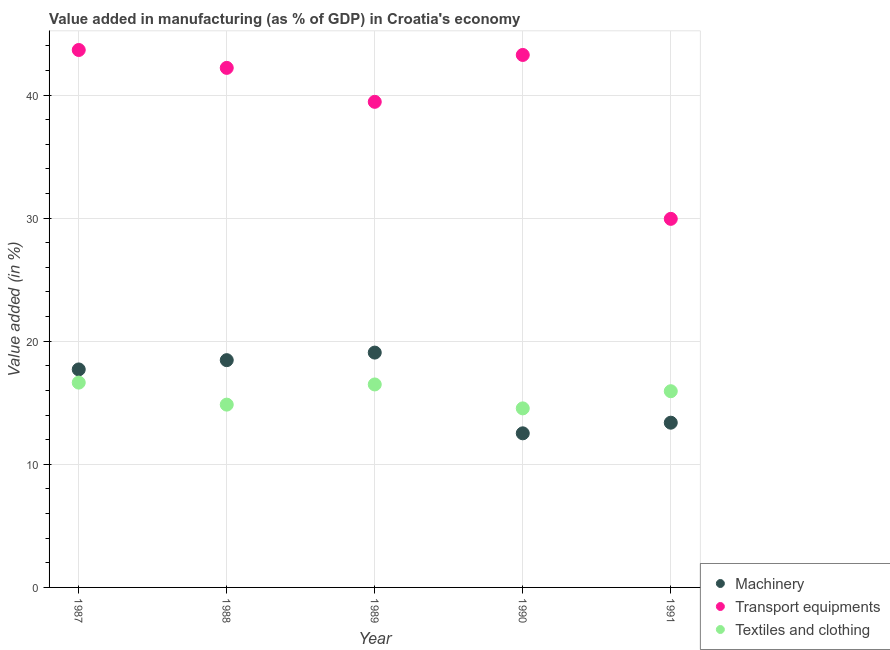How many different coloured dotlines are there?
Ensure brevity in your answer.  3. Is the number of dotlines equal to the number of legend labels?
Make the answer very short. Yes. What is the value added in manufacturing machinery in 1987?
Provide a succinct answer. 17.71. Across all years, what is the maximum value added in manufacturing textile and clothing?
Your answer should be compact. 16.64. Across all years, what is the minimum value added in manufacturing transport equipments?
Provide a short and direct response. 29.94. In which year was the value added in manufacturing textile and clothing maximum?
Provide a short and direct response. 1987. What is the total value added in manufacturing machinery in the graph?
Give a very brief answer. 81.15. What is the difference between the value added in manufacturing transport equipments in 1987 and that in 1990?
Keep it short and to the point. 0.4. What is the difference between the value added in manufacturing machinery in 1987 and the value added in manufacturing textile and clothing in 1988?
Offer a very short reply. 2.86. What is the average value added in manufacturing textile and clothing per year?
Provide a short and direct response. 15.69. In the year 1990, what is the difference between the value added in manufacturing transport equipments and value added in manufacturing textile and clothing?
Give a very brief answer. 28.71. What is the ratio of the value added in manufacturing machinery in 1988 to that in 1991?
Your answer should be compact. 1.38. Is the difference between the value added in manufacturing machinery in 1988 and 1990 greater than the difference between the value added in manufacturing transport equipments in 1988 and 1990?
Give a very brief answer. Yes. What is the difference between the highest and the second highest value added in manufacturing textile and clothing?
Give a very brief answer. 0.15. What is the difference between the highest and the lowest value added in manufacturing machinery?
Your answer should be very brief. 6.56. In how many years, is the value added in manufacturing machinery greater than the average value added in manufacturing machinery taken over all years?
Offer a very short reply. 3. Is the sum of the value added in manufacturing transport equipments in 1990 and 1991 greater than the maximum value added in manufacturing machinery across all years?
Your answer should be compact. Yes. Is the value added in manufacturing transport equipments strictly less than the value added in manufacturing machinery over the years?
Ensure brevity in your answer.  No. How many dotlines are there?
Ensure brevity in your answer.  3. What is the difference between two consecutive major ticks on the Y-axis?
Offer a terse response. 10. Are the values on the major ticks of Y-axis written in scientific E-notation?
Make the answer very short. No. What is the title of the graph?
Give a very brief answer. Value added in manufacturing (as % of GDP) in Croatia's economy. What is the label or title of the Y-axis?
Your answer should be very brief. Value added (in %). What is the Value added (in %) in Machinery in 1987?
Your answer should be very brief. 17.71. What is the Value added (in %) of Transport equipments in 1987?
Give a very brief answer. 43.66. What is the Value added (in %) in Textiles and clothing in 1987?
Offer a very short reply. 16.64. What is the Value added (in %) in Machinery in 1988?
Ensure brevity in your answer.  18.46. What is the Value added (in %) of Transport equipments in 1988?
Offer a terse response. 42.2. What is the Value added (in %) of Textiles and clothing in 1988?
Offer a terse response. 14.85. What is the Value added (in %) in Machinery in 1989?
Offer a terse response. 19.08. What is the Value added (in %) in Transport equipments in 1989?
Make the answer very short. 39.44. What is the Value added (in %) of Textiles and clothing in 1989?
Your response must be concise. 16.49. What is the Value added (in %) of Machinery in 1990?
Ensure brevity in your answer.  12.52. What is the Value added (in %) of Transport equipments in 1990?
Provide a succinct answer. 43.25. What is the Value added (in %) in Textiles and clothing in 1990?
Ensure brevity in your answer.  14.54. What is the Value added (in %) in Machinery in 1991?
Ensure brevity in your answer.  13.38. What is the Value added (in %) of Transport equipments in 1991?
Your response must be concise. 29.94. What is the Value added (in %) in Textiles and clothing in 1991?
Provide a succinct answer. 15.94. Across all years, what is the maximum Value added (in %) of Machinery?
Make the answer very short. 19.08. Across all years, what is the maximum Value added (in %) of Transport equipments?
Keep it short and to the point. 43.66. Across all years, what is the maximum Value added (in %) of Textiles and clothing?
Your answer should be compact. 16.64. Across all years, what is the minimum Value added (in %) in Machinery?
Provide a succinct answer. 12.52. Across all years, what is the minimum Value added (in %) in Transport equipments?
Your answer should be very brief. 29.94. Across all years, what is the minimum Value added (in %) in Textiles and clothing?
Give a very brief answer. 14.54. What is the total Value added (in %) in Machinery in the graph?
Offer a very short reply. 81.15. What is the total Value added (in %) in Transport equipments in the graph?
Provide a succinct answer. 198.5. What is the total Value added (in %) of Textiles and clothing in the graph?
Make the answer very short. 78.46. What is the difference between the Value added (in %) of Machinery in 1987 and that in 1988?
Offer a very short reply. -0.75. What is the difference between the Value added (in %) in Transport equipments in 1987 and that in 1988?
Ensure brevity in your answer.  1.45. What is the difference between the Value added (in %) of Textiles and clothing in 1987 and that in 1988?
Offer a terse response. 1.79. What is the difference between the Value added (in %) in Machinery in 1987 and that in 1989?
Offer a terse response. -1.37. What is the difference between the Value added (in %) in Transport equipments in 1987 and that in 1989?
Give a very brief answer. 4.21. What is the difference between the Value added (in %) in Textiles and clothing in 1987 and that in 1989?
Provide a succinct answer. 0.15. What is the difference between the Value added (in %) of Machinery in 1987 and that in 1990?
Give a very brief answer. 5.19. What is the difference between the Value added (in %) in Transport equipments in 1987 and that in 1990?
Provide a succinct answer. 0.4. What is the difference between the Value added (in %) of Textiles and clothing in 1987 and that in 1990?
Offer a terse response. 2.09. What is the difference between the Value added (in %) in Machinery in 1987 and that in 1991?
Offer a terse response. 4.33. What is the difference between the Value added (in %) of Transport equipments in 1987 and that in 1991?
Ensure brevity in your answer.  13.72. What is the difference between the Value added (in %) in Textiles and clothing in 1987 and that in 1991?
Keep it short and to the point. 0.7. What is the difference between the Value added (in %) in Machinery in 1988 and that in 1989?
Make the answer very short. -0.61. What is the difference between the Value added (in %) of Transport equipments in 1988 and that in 1989?
Provide a short and direct response. 2.76. What is the difference between the Value added (in %) in Textiles and clothing in 1988 and that in 1989?
Your answer should be very brief. -1.64. What is the difference between the Value added (in %) of Machinery in 1988 and that in 1990?
Your answer should be very brief. 5.94. What is the difference between the Value added (in %) in Transport equipments in 1988 and that in 1990?
Keep it short and to the point. -1.05. What is the difference between the Value added (in %) of Textiles and clothing in 1988 and that in 1990?
Your answer should be very brief. 0.31. What is the difference between the Value added (in %) in Machinery in 1988 and that in 1991?
Provide a short and direct response. 5.08. What is the difference between the Value added (in %) of Transport equipments in 1988 and that in 1991?
Ensure brevity in your answer.  12.26. What is the difference between the Value added (in %) of Textiles and clothing in 1988 and that in 1991?
Offer a terse response. -1.09. What is the difference between the Value added (in %) in Machinery in 1989 and that in 1990?
Make the answer very short. 6.56. What is the difference between the Value added (in %) of Transport equipments in 1989 and that in 1990?
Give a very brief answer. -3.81. What is the difference between the Value added (in %) of Textiles and clothing in 1989 and that in 1990?
Offer a terse response. 1.94. What is the difference between the Value added (in %) in Machinery in 1989 and that in 1991?
Give a very brief answer. 5.69. What is the difference between the Value added (in %) of Transport equipments in 1989 and that in 1991?
Keep it short and to the point. 9.51. What is the difference between the Value added (in %) in Textiles and clothing in 1989 and that in 1991?
Your answer should be compact. 0.55. What is the difference between the Value added (in %) of Machinery in 1990 and that in 1991?
Offer a terse response. -0.86. What is the difference between the Value added (in %) in Transport equipments in 1990 and that in 1991?
Offer a very short reply. 13.31. What is the difference between the Value added (in %) in Textiles and clothing in 1990 and that in 1991?
Your answer should be very brief. -1.39. What is the difference between the Value added (in %) in Machinery in 1987 and the Value added (in %) in Transport equipments in 1988?
Provide a short and direct response. -24.49. What is the difference between the Value added (in %) in Machinery in 1987 and the Value added (in %) in Textiles and clothing in 1988?
Your response must be concise. 2.86. What is the difference between the Value added (in %) in Transport equipments in 1987 and the Value added (in %) in Textiles and clothing in 1988?
Give a very brief answer. 28.81. What is the difference between the Value added (in %) in Machinery in 1987 and the Value added (in %) in Transport equipments in 1989?
Your answer should be compact. -21.74. What is the difference between the Value added (in %) of Machinery in 1987 and the Value added (in %) of Textiles and clothing in 1989?
Your answer should be compact. 1.22. What is the difference between the Value added (in %) of Transport equipments in 1987 and the Value added (in %) of Textiles and clothing in 1989?
Your answer should be very brief. 27.17. What is the difference between the Value added (in %) in Machinery in 1987 and the Value added (in %) in Transport equipments in 1990?
Provide a short and direct response. -25.54. What is the difference between the Value added (in %) in Machinery in 1987 and the Value added (in %) in Textiles and clothing in 1990?
Offer a terse response. 3.16. What is the difference between the Value added (in %) in Transport equipments in 1987 and the Value added (in %) in Textiles and clothing in 1990?
Provide a succinct answer. 29.11. What is the difference between the Value added (in %) of Machinery in 1987 and the Value added (in %) of Transport equipments in 1991?
Your response must be concise. -12.23. What is the difference between the Value added (in %) of Machinery in 1987 and the Value added (in %) of Textiles and clothing in 1991?
Your response must be concise. 1.77. What is the difference between the Value added (in %) in Transport equipments in 1987 and the Value added (in %) in Textiles and clothing in 1991?
Offer a terse response. 27.72. What is the difference between the Value added (in %) in Machinery in 1988 and the Value added (in %) in Transport equipments in 1989?
Your answer should be very brief. -20.98. What is the difference between the Value added (in %) of Machinery in 1988 and the Value added (in %) of Textiles and clothing in 1989?
Provide a succinct answer. 1.97. What is the difference between the Value added (in %) of Transport equipments in 1988 and the Value added (in %) of Textiles and clothing in 1989?
Your answer should be compact. 25.72. What is the difference between the Value added (in %) in Machinery in 1988 and the Value added (in %) in Transport equipments in 1990?
Make the answer very short. -24.79. What is the difference between the Value added (in %) in Machinery in 1988 and the Value added (in %) in Textiles and clothing in 1990?
Provide a succinct answer. 3.92. What is the difference between the Value added (in %) in Transport equipments in 1988 and the Value added (in %) in Textiles and clothing in 1990?
Your answer should be very brief. 27.66. What is the difference between the Value added (in %) in Machinery in 1988 and the Value added (in %) in Transport equipments in 1991?
Keep it short and to the point. -11.48. What is the difference between the Value added (in %) in Machinery in 1988 and the Value added (in %) in Textiles and clothing in 1991?
Your answer should be compact. 2.52. What is the difference between the Value added (in %) in Transport equipments in 1988 and the Value added (in %) in Textiles and clothing in 1991?
Make the answer very short. 26.26. What is the difference between the Value added (in %) in Machinery in 1989 and the Value added (in %) in Transport equipments in 1990?
Make the answer very short. -24.18. What is the difference between the Value added (in %) of Machinery in 1989 and the Value added (in %) of Textiles and clothing in 1990?
Provide a succinct answer. 4.53. What is the difference between the Value added (in %) of Transport equipments in 1989 and the Value added (in %) of Textiles and clothing in 1990?
Your answer should be compact. 24.9. What is the difference between the Value added (in %) in Machinery in 1989 and the Value added (in %) in Transport equipments in 1991?
Offer a terse response. -10.86. What is the difference between the Value added (in %) of Machinery in 1989 and the Value added (in %) of Textiles and clothing in 1991?
Provide a succinct answer. 3.14. What is the difference between the Value added (in %) of Transport equipments in 1989 and the Value added (in %) of Textiles and clothing in 1991?
Make the answer very short. 23.51. What is the difference between the Value added (in %) of Machinery in 1990 and the Value added (in %) of Transport equipments in 1991?
Provide a succinct answer. -17.42. What is the difference between the Value added (in %) of Machinery in 1990 and the Value added (in %) of Textiles and clothing in 1991?
Provide a succinct answer. -3.42. What is the difference between the Value added (in %) of Transport equipments in 1990 and the Value added (in %) of Textiles and clothing in 1991?
Provide a short and direct response. 27.31. What is the average Value added (in %) in Machinery per year?
Keep it short and to the point. 16.23. What is the average Value added (in %) in Transport equipments per year?
Provide a short and direct response. 39.7. What is the average Value added (in %) in Textiles and clothing per year?
Offer a very short reply. 15.69. In the year 1987, what is the difference between the Value added (in %) of Machinery and Value added (in %) of Transport equipments?
Make the answer very short. -25.95. In the year 1987, what is the difference between the Value added (in %) in Machinery and Value added (in %) in Textiles and clothing?
Make the answer very short. 1.07. In the year 1987, what is the difference between the Value added (in %) in Transport equipments and Value added (in %) in Textiles and clothing?
Your answer should be compact. 27.02. In the year 1988, what is the difference between the Value added (in %) in Machinery and Value added (in %) in Transport equipments?
Ensure brevity in your answer.  -23.74. In the year 1988, what is the difference between the Value added (in %) in Machinery and Value added (in %) in Textiles and clothing?
Your answer should be very brief. 3.61. In the year 1988, what is the difference between the Value added (in %) in Transport equipments and Value added (in %) in Textiles and clothing?
Ensure brevity in your answer.  27.35. In the year 1989, what is the difference between the Value added (in %) of Machinery and Value added (in %) of Transport equipments?
Provide a short and direct response. -20.37. In the year 1989, what is the difference between the Value added (in %) of Machinery and Value added (in %) of Textiles and clothing?
Make the answer very short. 2.59. In the year 1989, what is the difference between the Value added (in %) in Transport equipments and Value added (in %) in Textiles and clothing?
Offer a terse response. 22.96. In the year 1990, what is the difference between the Value added (in %) in Machinery and Value added (in %) in Transport equipments?
Your response must be concise. -30.73. In the year 1990, what is the difference between the Value added (in %) in Machinery and Value added (in %) in Textiles and clothing?
Your response must be concise. -2.03. In the year 1990, what is the difference between the Value added (in %) in Transport equipments and Value added (in %) in Textiles and clothing?
Your answer should be compact. 28.71. In the year 1991, what is the difference between the Value added (in %) of Machinery and Value added (in %) of Transport equipments?
Ensure brevity in your answer.  -16.56. In the year 1991, what is the difference between the Value added (in %) of Machinery and Value added (in %) of Textiles and clothing?
Make the answer very short. -2.56. In the year 1991, what is the difference between the Value added (in %) in Transport equipments and Value added (in %) in Textiles and clothing?
Give a very brief answer. 14. What is the ratio of the Value added (in %) in Machinery in 1987 to that in 1988?
Provide a short and direct response. 0.96. What is the ratio of the Value added (in %) of Transport equipments in 1987 to that in 1988?
Provide a succinct answer. 1.03. What is the ratio of the Value added (in %) in Textiles and clothing in 1987 to that in 1988?
Your answer should be very brief. 1.12. What is the ratio of the Value added (in %) of Machinery in 1987 to that in 1989?
Offer a very short reply. 0.93. What is the ratio of the Value added (in %) of Transport equipments in 1987 to that in 1989?
Offer a terse response. 1.11. What is the ratio of the Value added (in %) in Textiles and clothing in 1987 to that in 1989?
Give a very brief answer. 1.01. What is the ratio of the Value added (in %) of Machinery in 1987 to that in 1990?
Ensure brevity in your answer.  1.41. What is the ratio of the Value added (in %) in Transport equipments in 1987 to that in 1990?
Make the answer very short. 1.01. What is the ratio of the Value added (in %) in Textiles and clothing in 1987 to that in 1990?
Give a very brief answer. 1.14. What is the ratio of the Value added (in %) in Machinery in 1987 to that in 1991?
Your answer should be very brief. 1.32. What is the ratio of the Value added (in %) in Transport equipments in 1987 to that in 1991?
Offer a terse response. 1.46. What is the ratio of the Value added (in %) of Textiles and clothing in 1987 to that in 1991?
Keep it short and to the point. 1.04. What is the ratio of the Value added (in %) in Machinery in 1988 to that in 1989?
Ensure brevity in your answer.  0.97. What is the ratio of the Value added (in %) in Transport equipments in 1988 to that in 1989?
Ensure brevity in your answer.  1.07. What is the ratio of the Value added (in %) in Textiles and clothing in 1988 to that in 1989?
Offer a very short reply. 0.9. What is the ratio of the Value added (in %) of Machinery in 1988 to that in 1990?
Make the answer very short. 1.47. What is the ratio of the Value added (in %) of Transport equipments in 1988 to that in 1990?
Provide a short and direct response. 0.98. What is the ratio of the Value added (in %) in Textiles and clothing in 1988 to that in 1990?
Your answer should be very brief. 1.02. What is the ratio of the Value added (in %) in Machinery in 1988 to that in 1991?
Provide a short and direct response. 1.38. What is the ratio of the Value added (in %) of Transport equipments in 1988 to that in 1991?
Give a very brief answer. 1.41. What is the ratio of the Value added (in %) in Textiles and clothing in 1988 to that in 1991?
Offer a terse response. 0.93. What is the ratio of the Value added (in %) in Machinery in 1989 to that in 1990?
Your answer should be compact. 1.52. What is the ratio of the Value added (in %) of Transport equipments in 1989 to that in 1990?
Give a very brief answer. 0.91. What is the ratio of the Value added (in %) of Textiles and clothing in 1989 to that in 1990?
Offer a terse response. 1.13. What is the ratio of the Value added (in %) in Machinery in 1989 to that in 1991?
Your answer should be very brief. 1.43. What is the ratio of the Value added (in %) in Transport equipments in 1989 to that in 1991?
Provide a short and direct response. 1.32. What is the ratio of the Value added (in %) in Textiles and clothing in 1989 to that in 1991?
Provide a succinct answer. 1.03. What is the ratio of the Value added (in %) of Machinery in 1990 to that in 1991?
Your response must be concise. 0.94. What is the ratio of the Value added (in %) of Transport equipments in 1990 to that in 1991?
Your answer should be compact. 1.44. What is the ratio of the Value added (in %) in Textiles and clothing in 1990 to that in 1991?
Provide a succinct answer. 0.91. What is the difference between the highest and the second highest Value added (in %) in Machinery?
Your answer should be very brief. 0.61. What is the difference between the highest and the second highest Value added (in %) in Transport equipments?
Provide a short and direct response. 0.4. What is the difference between the highest and the second highest Value added (in %) in Textiles and clothing?
Provide a succinct answer. 0.15. What is the difference between the highest and the lowest Value added (in %) of Machinery?
Provide a succinct answer. 6.56. What is the difference between the highest and the lowest Value added (in %) of Transport equipments?
Make the answer very short. 13.72. What is the difference between the highest and the lowest Value added (in %) of Textiles and clothing?
Make the answer very short. 2.09. 